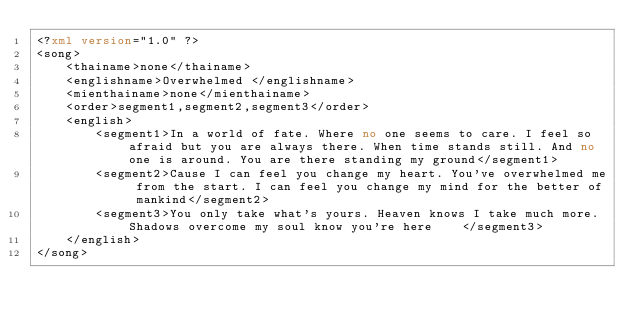Convert code to text. <code><loc_0><loc_0><loc_500><loc_500><_XML_><?xml version="1.0" ?>
<song>
	<thainame>none</thainame>
	<englishname>Overwhelmed </englishname>
	<mienthainame>none</mienthainame>
	<order>segment1,segment2,segment3</order>
	<english>
		<segment1>In a world of fate. Where no one seems to care. I feel so afraid but you are always there. When time stands still. And no one is around. You are there standing my ground</segment1>
		<segment2>Cause I can feel you change my heart. You've overwhelmed me from the start. I can feel you change my mind for the better of mankind</segment2>
		<segment3>You only take what's yours. Heaven knows I take much more. Shadows overcome my soul know you're here    </segment3>
	</english>
</song>
</code> 